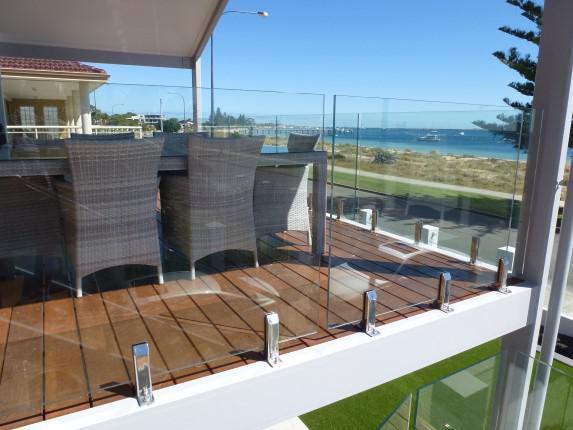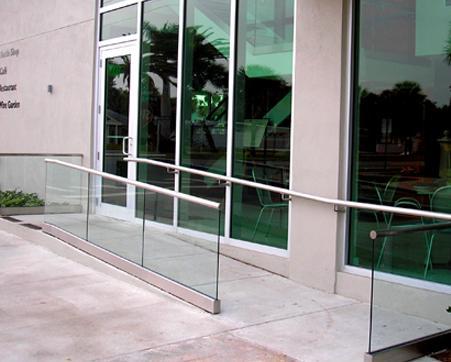The first image is the image on the left, the second image is the image on the right. Evaluate the accuracy of this statement regarding the images: "A building with at least 3 stories has glass deck railings outside.". Is it true? Answer yes or no. No. The first image is the image on the left, the second image is the image on the right. Examine the images to the left and right. Is the description "The right image contains at least three balconies on a building." accurate? Answer yes or no. No. 